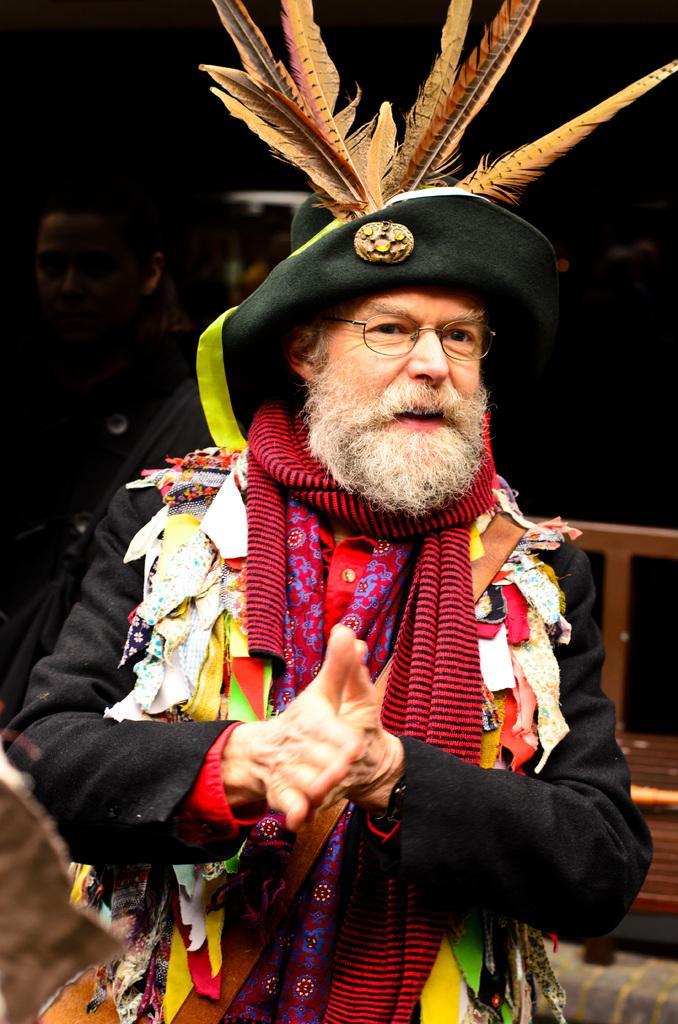Please provide a concise description of this image. Here, we can see a man standing and he is wearing a hat, there is a dark background. 